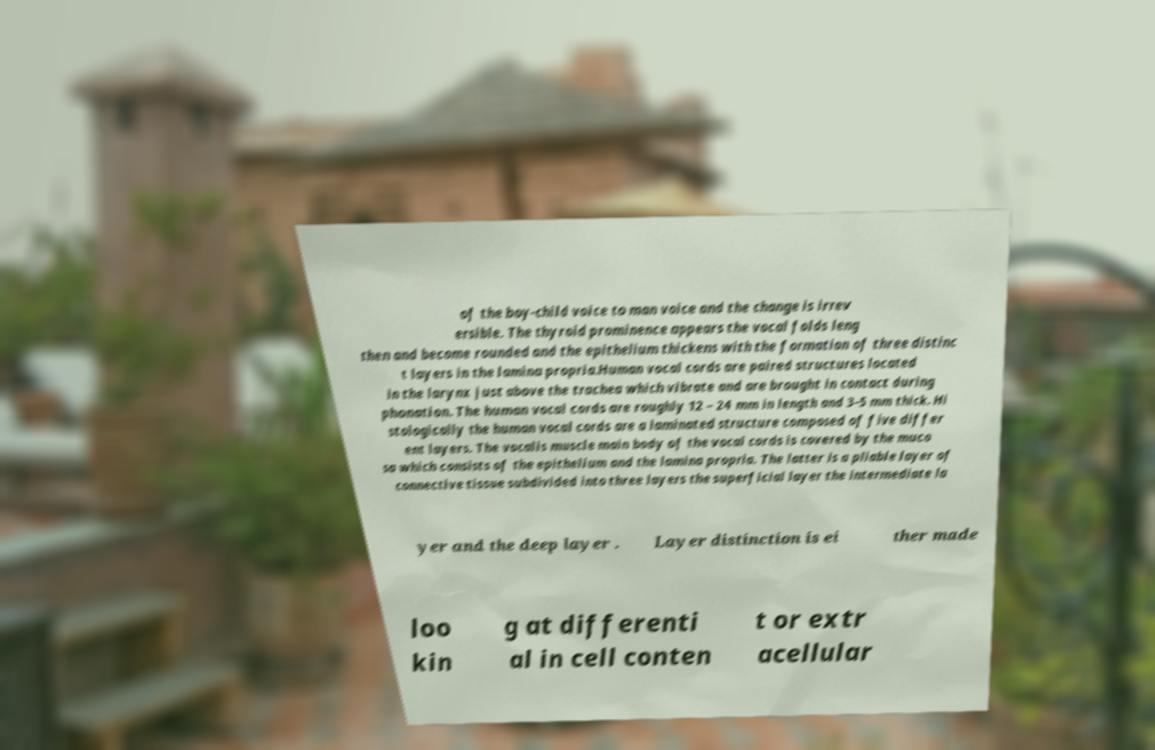I need the written content from this picture converted into text. Can you do that? of the boy-child voice to man voice and the change is irrev ersible. The thyroid prominence appears the vocal folds leng then and become rounded and the epithelium thickens with the formation of three distinc t layers in the lamina propria.Human vocal cords are paired structures located in the larynx just above the trachea which vibrate and are brought in contact during phonation. The human vocal cords are roughly 12 – 24 mm in length and 3–5 mm thick. Hi stologically the human vocal cords are a laminated structure composed of five differ ent layers. The vocalis muscle main body of the vocal cords is covered by the muco sa which consists of the epithelium and the lamina propria. The latter is a pliable layer of connective tissue subdivided into three layers the superficial layer the intermediate la yer and the deep layer . Layer distinction is ei ther made loo kin g at differenti al in cell conten t or extr acellular 